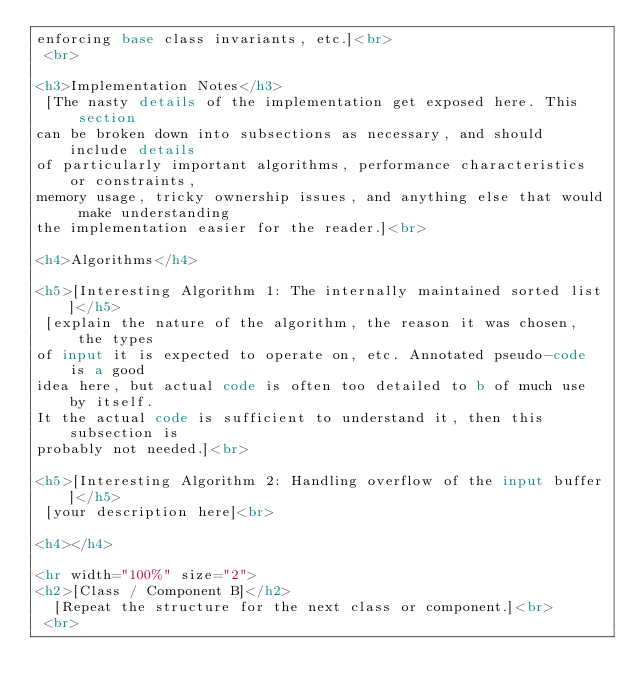Convert code to text. <code><loc_0><loc_0><loc_500><loc_500><_HTML_>enforcing base class invariants, etc.]<br>
 <br>
 
<h3>Implementation Notes</h3>
 [The nasty details of the implementation get exposed here. This section
can be broken down into subsections as necessary, and should include details 
of particularly important algorithms, performance characteristics or constraints, 
memory usage, tricky ownership issues, and anything else that would make understanding
the implementation easier for the reader.]<br>
 
<h4>Algorithms</h4>
 
<h5>[Interesting Algorithm 1: The internally maintained sorted list]</h5>
 [explain the nature of the algorithm, the reason it was chosen, the types 
of input it is expected to operate on, etc. Annotated pseudo-code is a good 
idea here, but actual code is often too detailed to b of much use by itself. 
It the actual code is sufficient to understand it, then this subsection is 
probably not needed.]<br>
 
<h5>[Interesting Algorithm 2: Handling overflow of the input buffer]</h5>
 [your description here]<br>
 
<h4></h4>
 
<hr width="100%" size="2"> 
<h2>[Class / Component B]</h2>
  [Repeat the structure for the next class or component.]<br>
 <br>
 </code> 